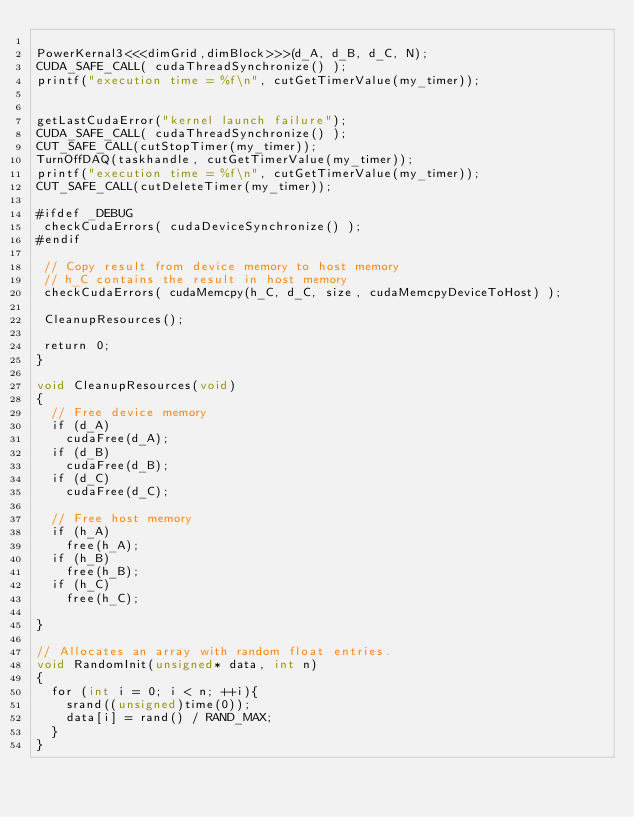<code> <loc_0><loc_0><loc_500><loc_500><_Cuda_>
PowerKernal3<<<dimGrid,dimBlock>>>(d_A, d_B, d_C, N);
CUDA_SAFE_CALL( cudaThreadSynchronize() );
printf("execution time = %f\n", cutGetTimerValue(my_timer));


getLastCudaError("kernel launch failure");
CUDA_SAFE_CALL( cudaThreadSynchronize() );
CUT_SAFE_CALL(cutStopTimer(my_timer));
TurnOffDAQ(taskhandle, cutGetTimerValue(my_timer));
printf("execution time = %f\n", cutGetTimerValue(my_timer));
CUT_SAFE_CALL(cutDeleteTimer(my_timer)); 

#ifdef _DEBUG
 checkCudaErrors( cudaDeviceSynchronize() );
#endif

 // Copy result from device memory to host memory
 // h_C contains the result in host memory
 checkCudaErrors( cudaMemcpy(h_C, d_C, size, cudaMemcpyDeviceToHost) );
 
 CleanupResources();

 return 0;
}

void CleanupResources(void)
{
  // Free device memory
  if (d_A)
	cudaFree(d_A);
  if (d_B)
	cudaFree(d_B);
  if (d_C)
	cudaFree(d_C);

  // Free host memory
  if (h_A)
	free(h_A);
  if (h_B)
	free(h_B);
  if (h_C)
	free(h_C);

}

// Allocates an array with random float entries.
void RandomInit(unsigned* data, int n)
{
  for (int i = 0; i < n; ++i){
	srand((unsigned)time(0));  
	data[i] = rand() / RAND_MAX;
  }
}






</code> 